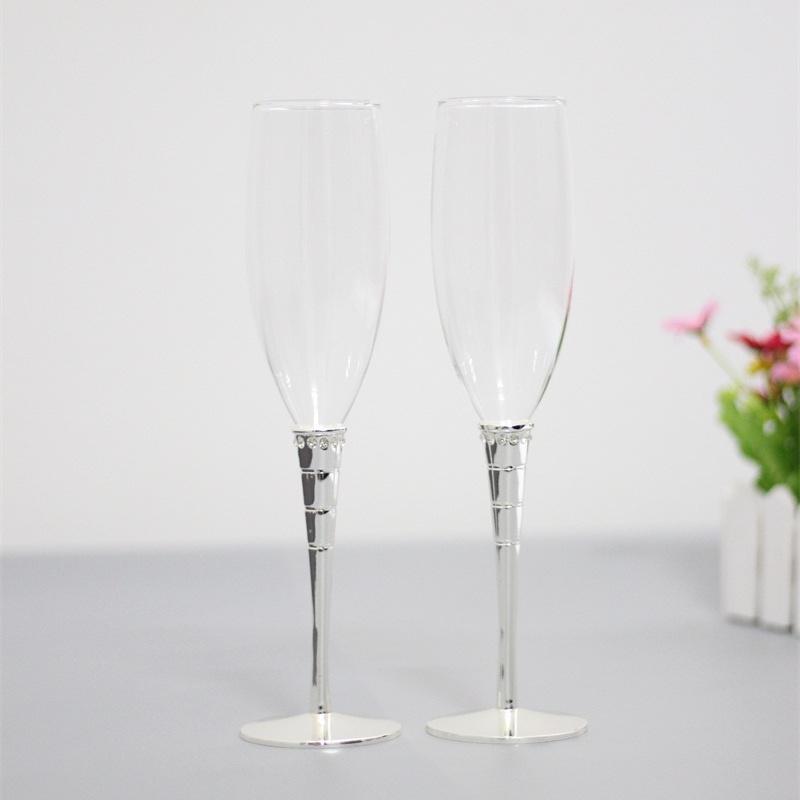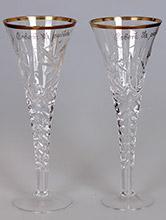The first image is the image on the left, the second image is the image on the right. Evaluate the accuracy of this statement regarding the images: "There are four champagne flutes with silver bases.". Is it true? Answer yes or no. No. The first image is the image on the left, the second image is the image on the right. Considering the images on both sides, is "There are four clear glasses with silver stems." valid? Answer yes or no. No. 